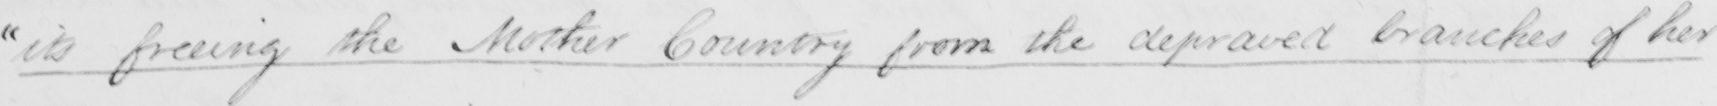Can you read and transcribe this handwriting? " its freeing the Mother Country from the depraved branches of her 